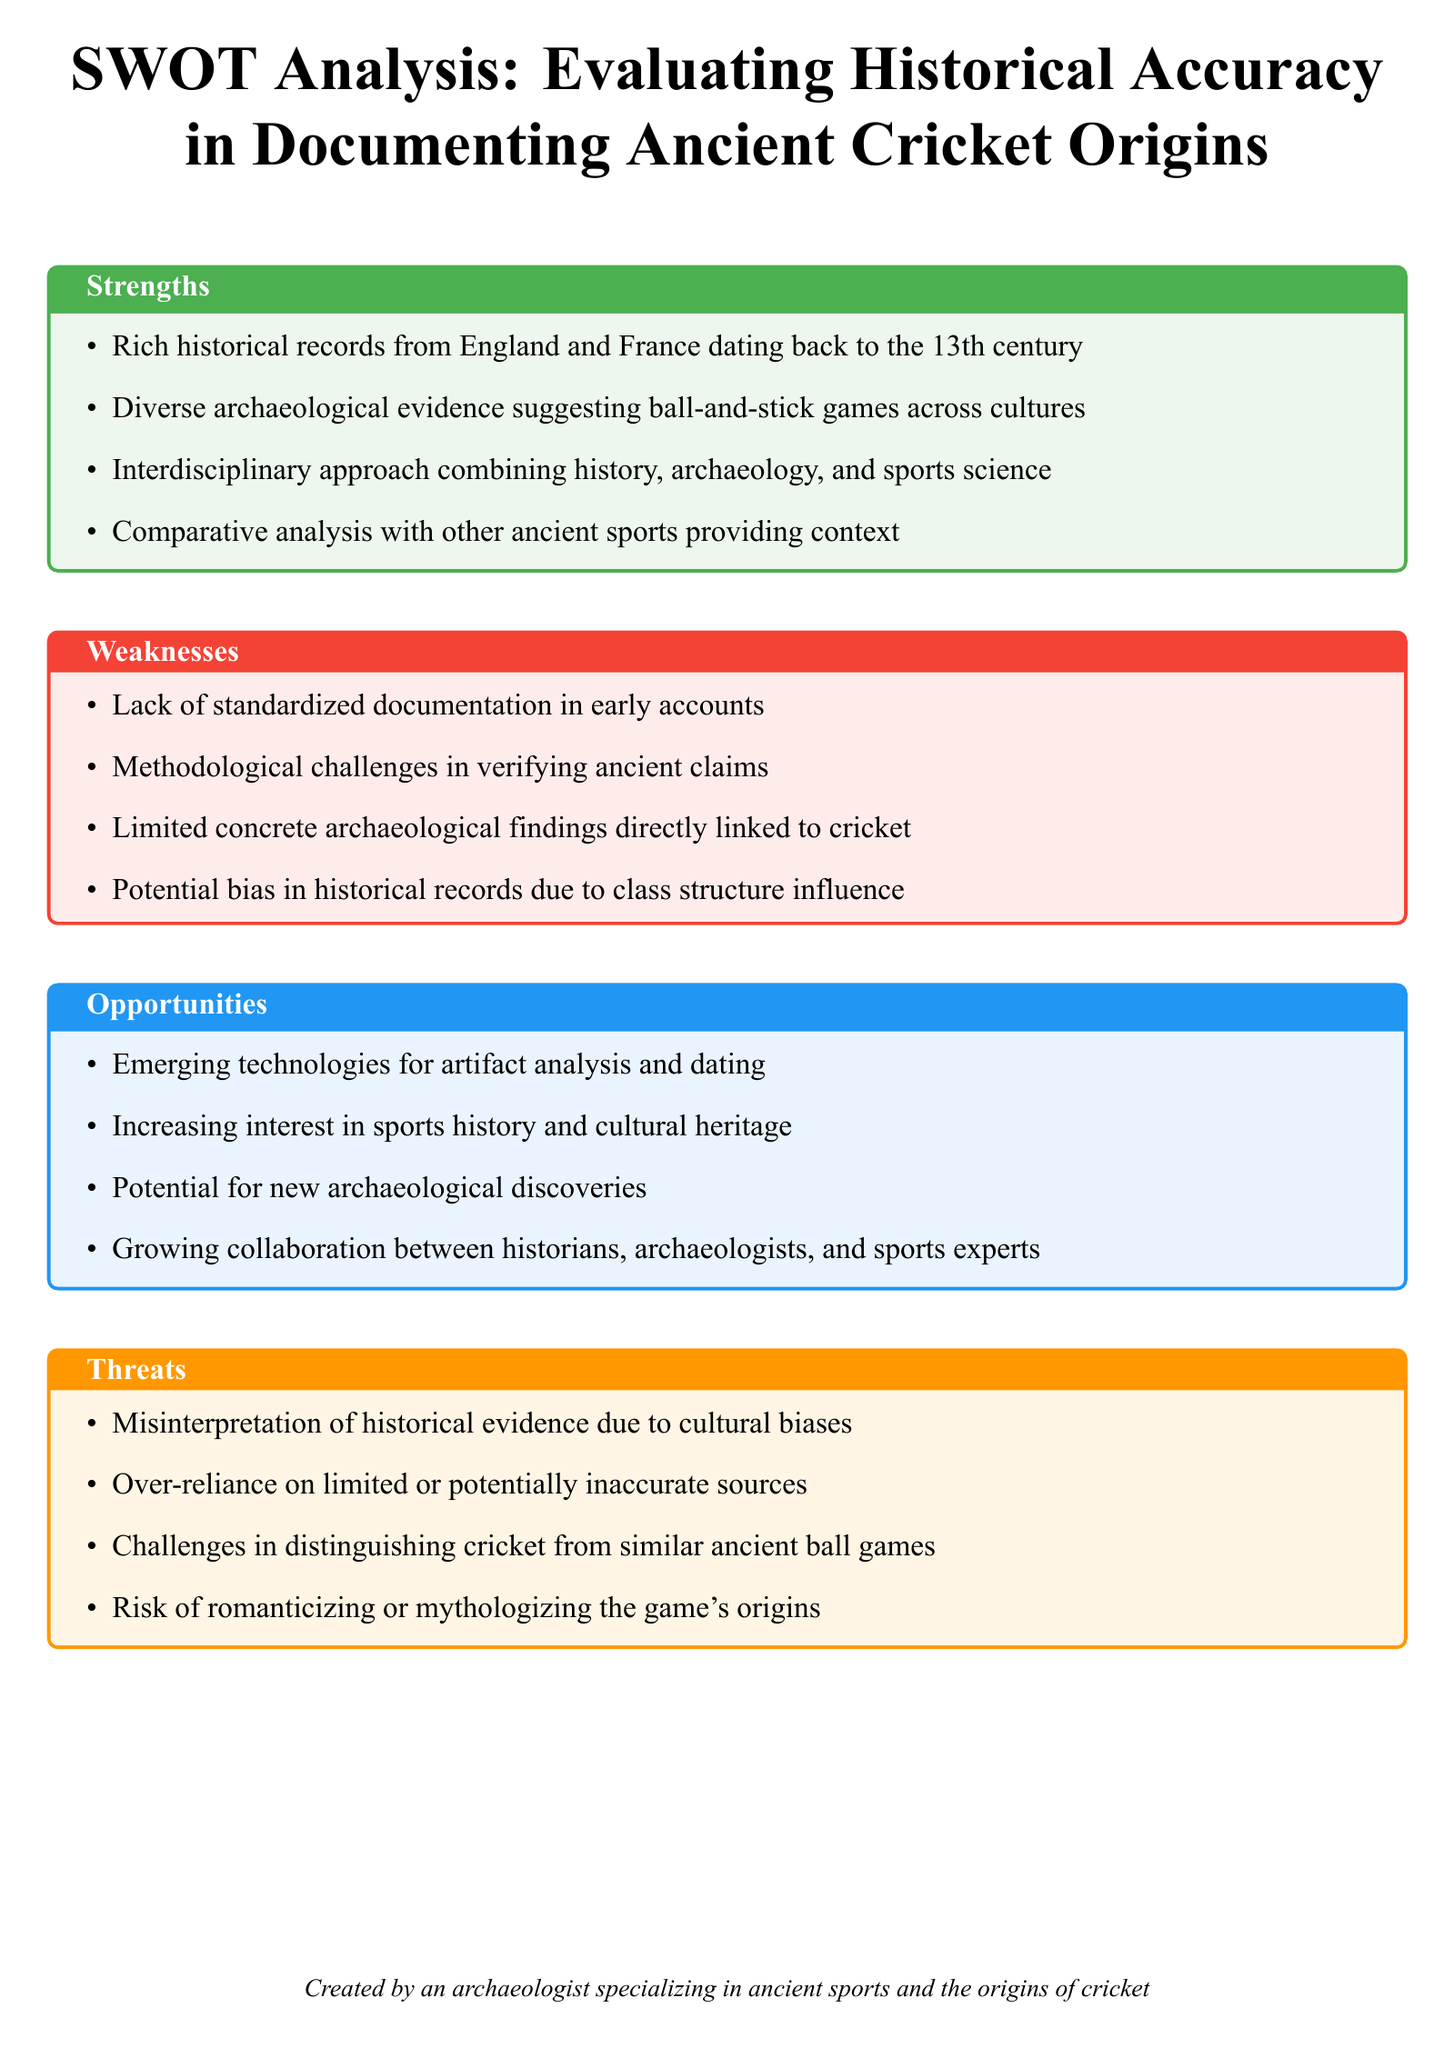What are the four categories of the SWOT analysis? The document categorizes the SWOT analysis into Strengths, Weaknesses, Opportunities, and Threats.
Answer: Strengths, Weaknesses, Opportunities, Threats What century do the historical records of cricket date back to? The document states that historical records from England and France date back to the 13th century.
Answer: 13th century What is one methodological challenge mentioned in the weaknesses? The document lists "methodological challenges in verifying ancient claims" as one of the weaknesses.
Answer: Methodological challenges in verifying ancient claims Which ancient sports provide context for evaluating historical accuracy? The document mentions using a "comparative analysis with other ancient sports" to provide contextual understanding.
Answer: Other ancient sports What emerging technology can aid in analyzing artifacts? The document mentions "emerging technologies for artifact analysis and dating" as an opportunity in the analysis.
Answer: Artifact analysis and dating What influence is suggested to potentially bias historical records? The document indicates that "class structure influence" could affect the bias in historical records.
Answer: Class structure influence What is a risk associated with interpreting the game's origins? The document mentions the "risk of romanticizing or mythologizing the game's origins" as a threat.
Answer: Romanticizing or mythologizing How many types of collaboration are mentioned as an opportunity? The document states "growing collaboration between historians, archaeologists, and sports experts," which involves three types.
Answer: Three types What type of evidence is limited according to the weaknesses section? The document states there are "limited concrete archaeological findings directly linked to cricket."
Answer: Concrete archaeological findings 